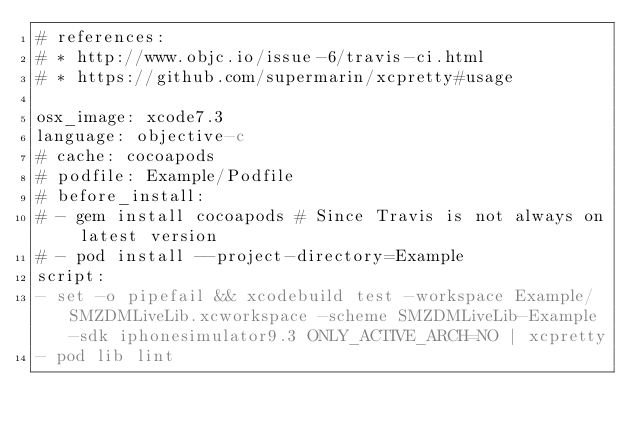Convert code to text. <code><loc_0><loc_0><loc_500><loc_500><_YAML_># references:
# * http://www.objc.io/issue-6/travis-ci.html
# * https://github.com/supermarin/xcpretty#usage

osx_image: xcode7.3
language: objective-c
# cache: cocoapods
# podfile: Example/Podfile
# before_install:
# - gem install cocoapods # Since Travis is not always on latest version
# - pod install --project-directory=Example
script:
- set -o pipefail && xcodebuild test -workspace Example/SMZDMLiveLib.xcworkspace -scheme SMZDMLiveLib-Example -sdk iphonesimulator9.3 ONLY_ACTIVE_ARCH=NO | xcpretty
- pod lib lint
</code> 